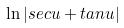Convert formula to latex. <formula><loc_0><loc_0><loc_500><loc_500>\ln | s e c u + t a n u |</formula> 